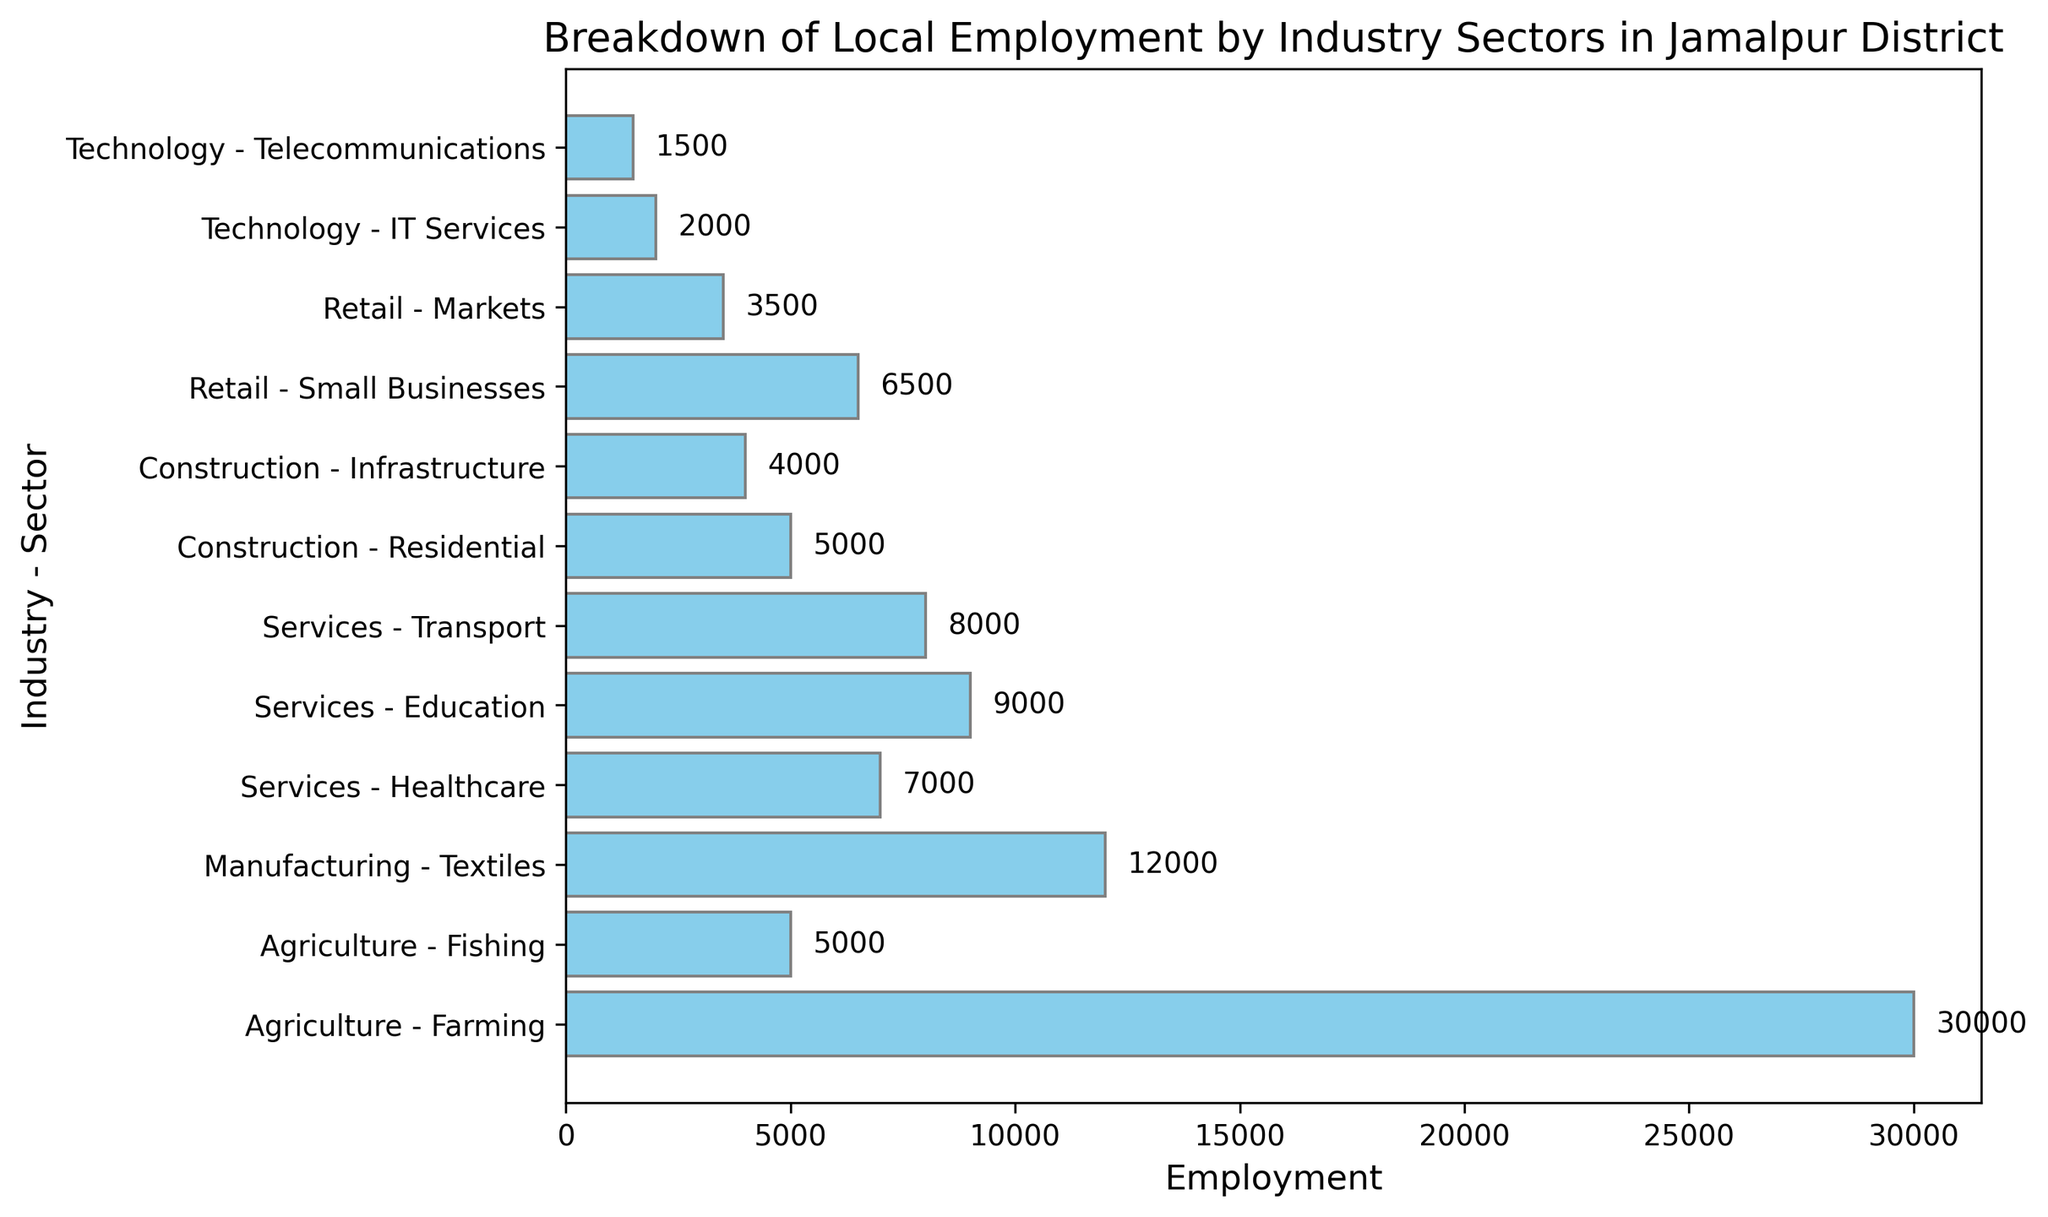what is the total employment in the Agriculture industry? Sum the employment figures for the Farming and Fishing sectors within the Agriculture industry: 30,000 (Farming) + 5,000 (Fishing) = 35,000.
Answer: 35,000 which sector has the highest employment in Jamalpur District? Compare the employment figures for all sectors, Farming (30,000) has the highest value.
Answer: Farming how does employment in Technology compare to Construction sectors? Sum employment figures for Technology sectors (IT Services: 2,000 + Telecommunications: 1,500 = 3,500) and Construction sectors (Residential: 5,000 + Infrastructure: 4,000 = 9,000). 9,000 (Construction) is greater than 3,500 (Technology).
Answer: Construction is greater which industry shows the least employment, and what are the figures for its sectors? Identify the total employment for each industry: Technology has the least (2,000 IT Services + 1,500 Telecommunications = 3,500).
Answer: Technology, 3,500 is the combined employment in Services greater than in Manufacturing and Retail combined? Sum the employment for Services (Healthcare: 7,000 + Education: 9,000 + Transport: 8,000 = 24,000), for Manufacturing (Textiles: 12,000), and for Retail (Small Businesses: 6,500 + Markets: 3,500 = 10,000). Compare sums: 24,000 (Services) vs. 22,000 (Manufacturing + Retail).
Answer: Yes, Services is greater what is the average employment per sector in Agriculture? Average employment in Agriculture = (30,000 Farming + 5,000 Fishing) / 2 = 17,500.
Answer: 17,500 how many sectors have employment figures between 5,000 and 10,000? Identify sectors: Fishing (5,000), Transport (8,000), Healthcare (7,000), Education (9,000), Small Businesses (6,500).
Answer: 5 which has higher employment: Healthcare or Education sector? Compare employment figures: 7,000 (Healthcare) vs. 9,000 (Education).
Answer: Education what's the difference in employment between Textiles and Small Businesses? Calculate the difference: 12,000 (Textiles) - 6,500 (Small Businesses) = 5,500.
Answer: 5,500 what's the employment ratio of Farming to Telecommunications sectors? Calculate the ratio: 30,000 (Farming) / 1,500 (Telecommunications) = 20:1.
Answer: 20:1 